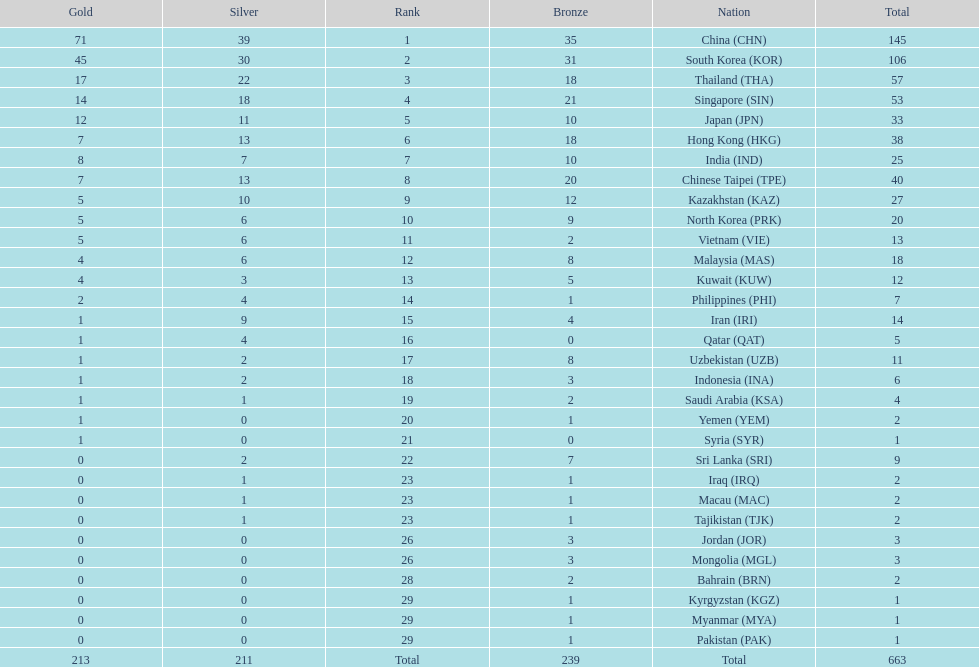How many nations earned at least ten bronze medals? 9. 